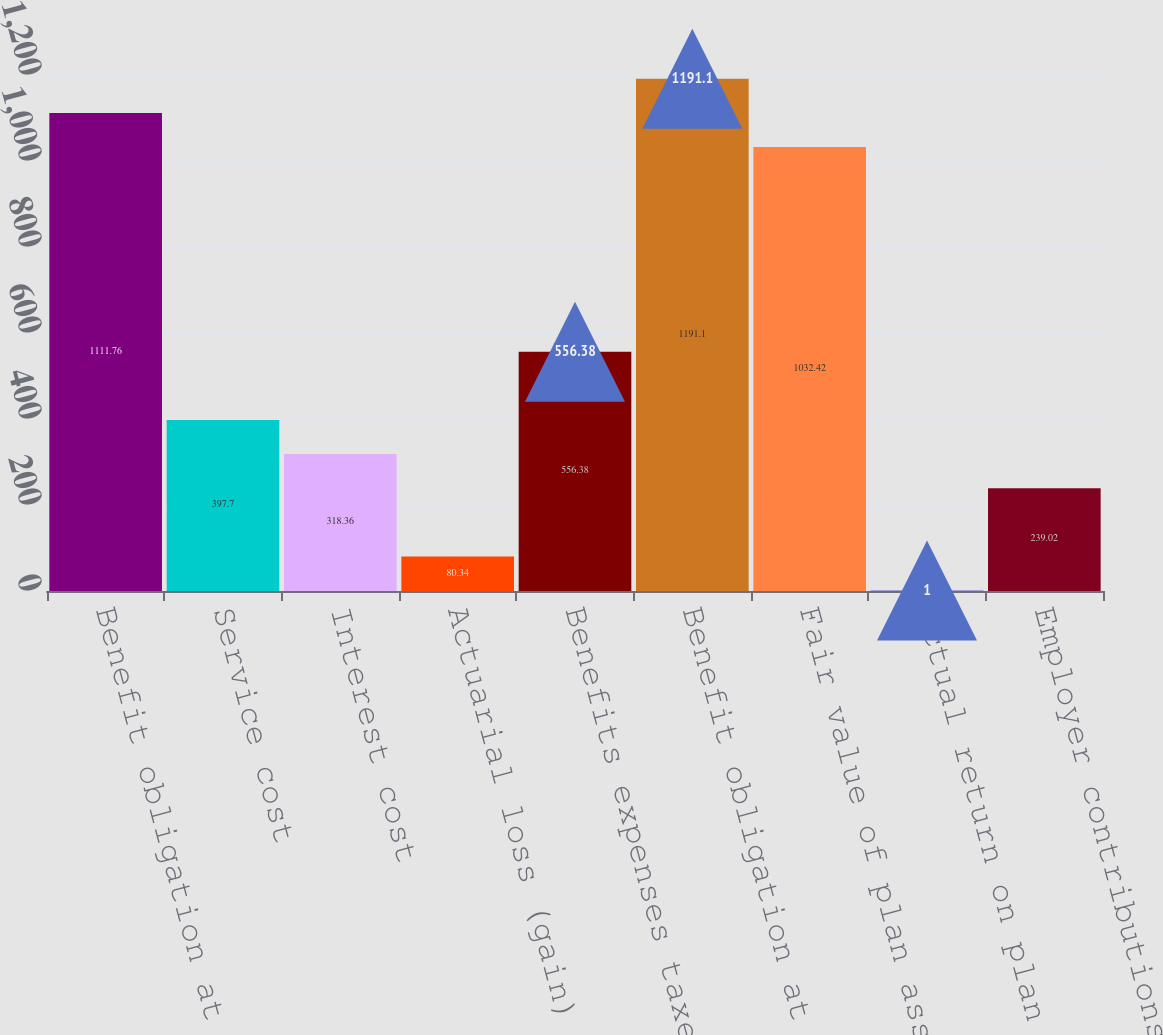Convert chart. <chart><loc_0><loc_0><loc_500><loc_500><bar_chart><fcel>Benefit obligation at<fcel>Service cost<fcel>Interest cost<fcel>Actuarial loss (gain)<fcel>Benefits expenses taxes and<fcel>Benefit obligation at end of<fcel>Fair value of plan assets at<fcel>Actual return on plan assets<fcel>Employer contributions<nl><fcel>1111.76<fcel>397.7<fcel>318.36<fcel>80.34<fcel>556.38<fcel>1191.1<fcel>1032.42<fcel>1<fcel>239.02<nl></chart> 